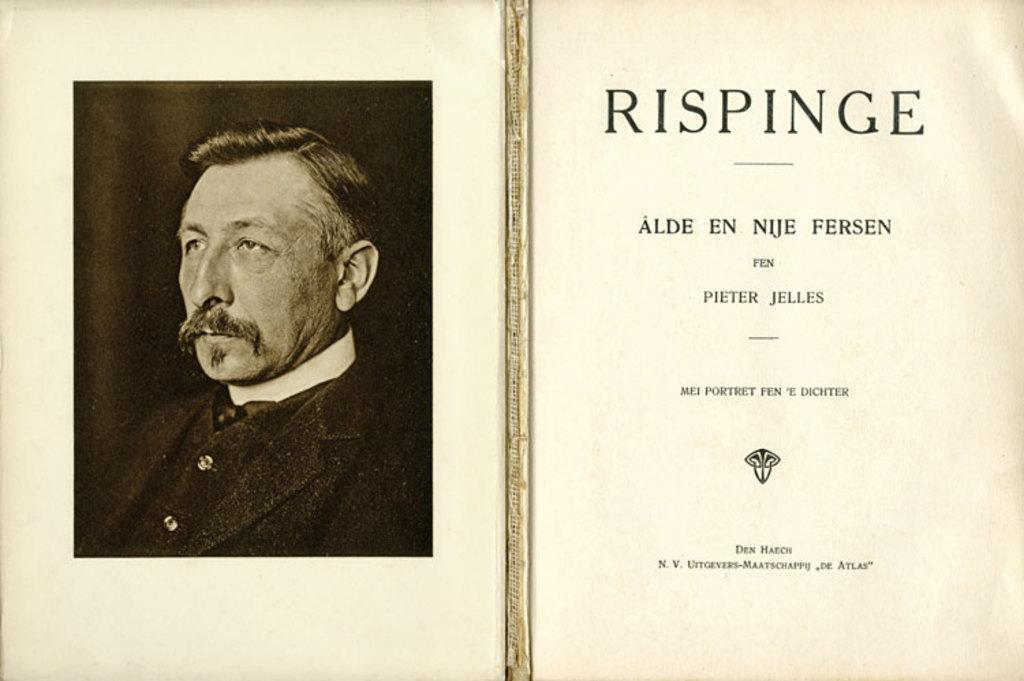What can be found on the right side of the poster? There is text on the right side of the poster. What is depicted on the left side of the poster? There is an image of a person on the left side of the poster. Are the text and image in the foreground or background of the poster? Both the text and image are in the foreground of the poster. What flavor of ice cream is the person holding in the image? There is no ice cream present in the image, nor is there a person holding anything. 